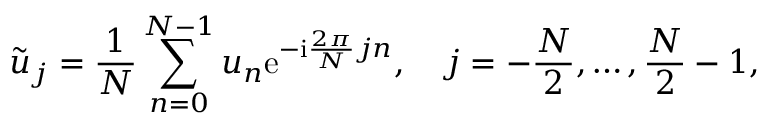Convert formula to latex. <formula><loc_0><loc_0><loc_500><loc_500>\tilde { u } _ { j } = \frac { 1 } { N } \sum _ { n = 0 } ^ { N - 1 } u _ { n } e ^ { - i \frac { 2 \pi } { N } j n } , \quad j = - \frac { N } { 2 } , \dots , \frac { N } { 2 } - 1 ,</formula> 